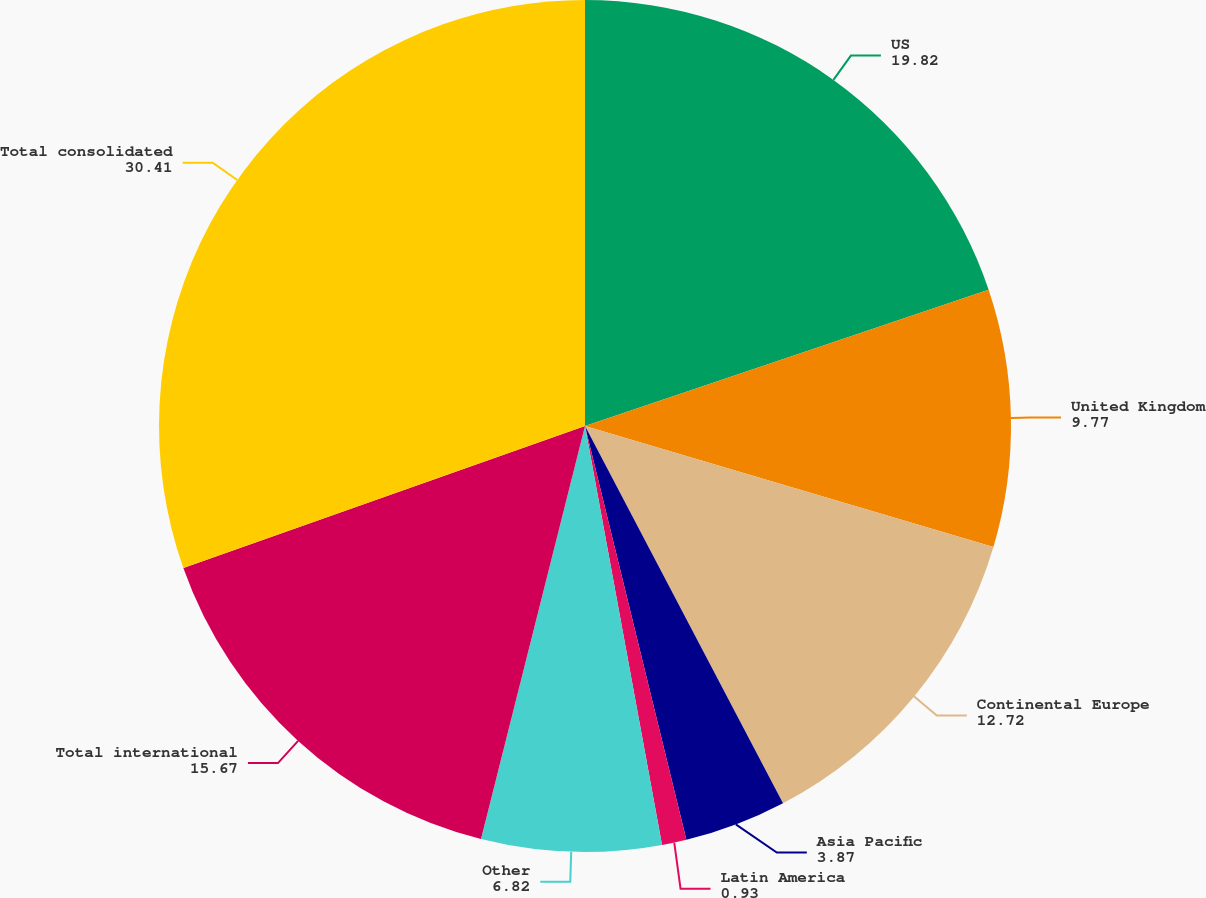Convert chart to OTSL. <chart><loc_0><loc_0><loc_500><loc_500><pie_chart><fcel>US<fcel>United Kingdom<fcel>Continental Europe<fcel>Asia Pacific<fcel>Latin America<fcel>Other<fcel>Total international<fcel>Total consolidated<nl><fcel>19.82%<fcel>9.77%<fcel>12.72%<fcel>3.87%<fcel>0.93%<fcel>6.82%<fcel>15.67%<fcel>30.41%<nl></chart> 